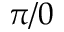Convert formula to latex. <formula><loc_0><loc_0><loc_500><loc_500>\pi / 0</formula> 